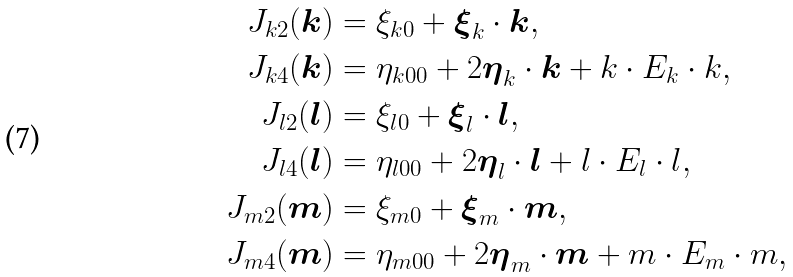Convert formula to latex. <formula><loc_0><loc_0><loc_500><loc_500>J _ { k 2 } ( \boldsymbol k ) & = \xi _ { k 0 } + \boldsymbol \xi _ { k } \cdot \boldsymbol k , \\ J _ { k 4 } ( \boldsymbol k ) & = \eta _ { k 0 0 } + 2 \boldsymbol \eta _ { k } \cdot \boldsymbol k + k \cdot E _ { k } \cdot k , \\ J _ { l 2 } ( \boldsymbol l ) & = \xi _ { l 0 } + \boldsymbol \xi _ { l } \cdot \boldsymbol l , \\ J _ { l 4 } ( \boldsymbol l ) & = \eta _ { l 0 0 } + 2 \boldsymbol \eta _ { l } \cdot \boldsymbol l + l \cdot E _ { l } \cdot l , \\ J _ { m 2 } ( \boldsymbol m ) & = \xi _ { m 0 } + \boldsymbol \xi _ { m } \cdot \boldsymbol m , \\ J _ { m 4 } ( \boldsymbol m ) & = \eta _ { m 0 0 } + 2 \boldsymbol \eta _ { m } \cdot \boldsymbol m + m \cdot E _ { m } \cdot m ,</formula> 